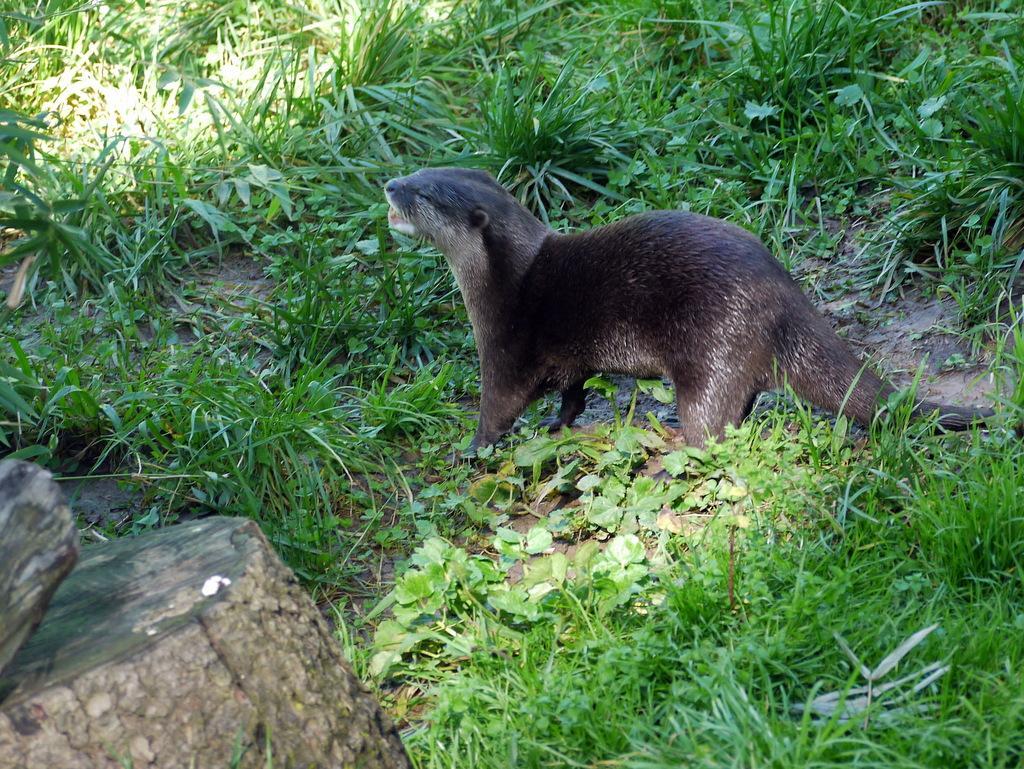Describe this image in one or two sentences. This picture is clicked outside. In the center there is a black color animal seems to be standing on the ground and we can see the green grass and some plants. On the left corner there are some objects. 